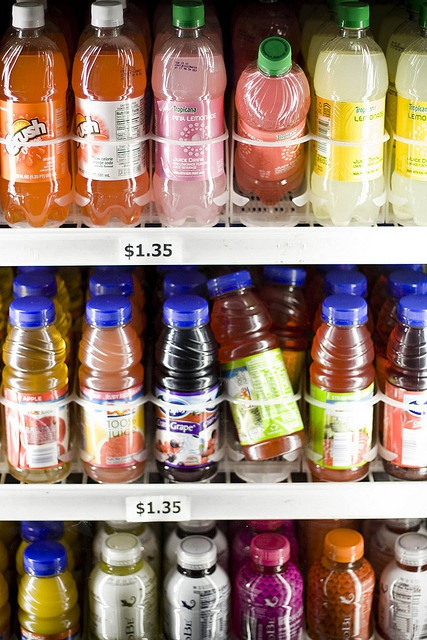Describe the objects in this image and their specific colors. I can see refrigerator in white, black, maroon, brown, and lightpink tones, bottle in black, lightgray, maroon, and darkgray tones, bottle in black, beige, khaki, and olive tones, bottle in black, lightpink, lightgray, brown, and darkgray tones, and bottle in black, lightgray, brown, maroon, and darkgray tones in this image. 